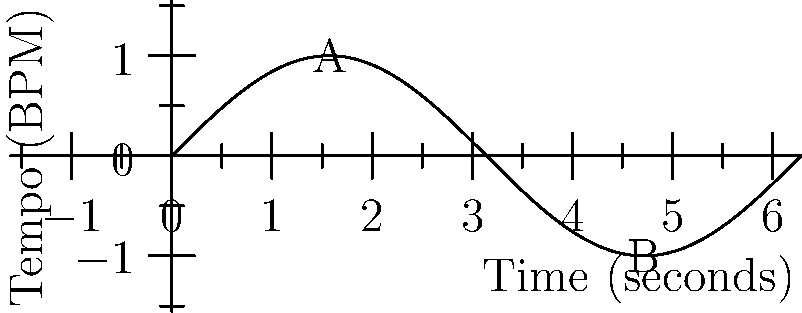As a DJ, you're experimenting with tempo changes in a new remix. The graph represents the tempo variation over time, where the y-axis shows the deviation from the base tempo in beats per minute (BPM). At which point, A or B, is the rate of tempo change the greatest, and what is this maximum rate of change in BPM per second? To solve this problem, we need to analyze the rate of change of the sine function, which is represented by its derivative. Let's approach this step-by-step:

1) The sine function is given by $y = \sin(x)$, where $y$ represents the tempo deviation in BPM and $x$ represents time in seconds.

2) The derivative of $\sin(x)$ is $\cos(x)$. This represents the rate of change of tempo at any given point.

3) The maximum absolute value of $\cos(x)$ is 1, which occurs at $x = 0, \pi, 2\pi, \text{ etc.}$

4) On our graph:
   - Point A is at $x = \pi/2$, where $\sin(x) = 1$
   - Point B is at $x = 3\pi/2$, where $\sin(x) = -1$

5) The rate of change at these points is:
   - At A: $\cos(\pi/2) = 0$
   - At B: $\cos(3\pi/2) = 0$

6) The rate of change is actually zero at both A and B, as these are the peaks of the sine wave where the tempo momentarily stops changing.

7) The maximum rate of change occurs at the zero crossings of the sine wave, which are at $x = 0, \pi, 2\pi, \text{ etc.}$

8) At these points, $\cos(x) = \pm 1$

9) To find the actual rate in BPM per second, we need to consider the amplitude and frequency of the wave:
   - The amplitude is 1 BPM (the wave goes from -1 to 1)
   - One full cycle occurs over $2\pi$ seconds

10) Therefore, the angular frequency $\omega = 1$ rad/s

11) The maximum rate of change is thus:
    $\text{Rate} = \text{Amplitude} \times \omega = 1 \text{ BPM} \times 1 \text{ rad/s} = 1 \text{ BPM/s}$
Answer: Neither A nor B; maximum rate is 1 BPM/s at zero crossings. 